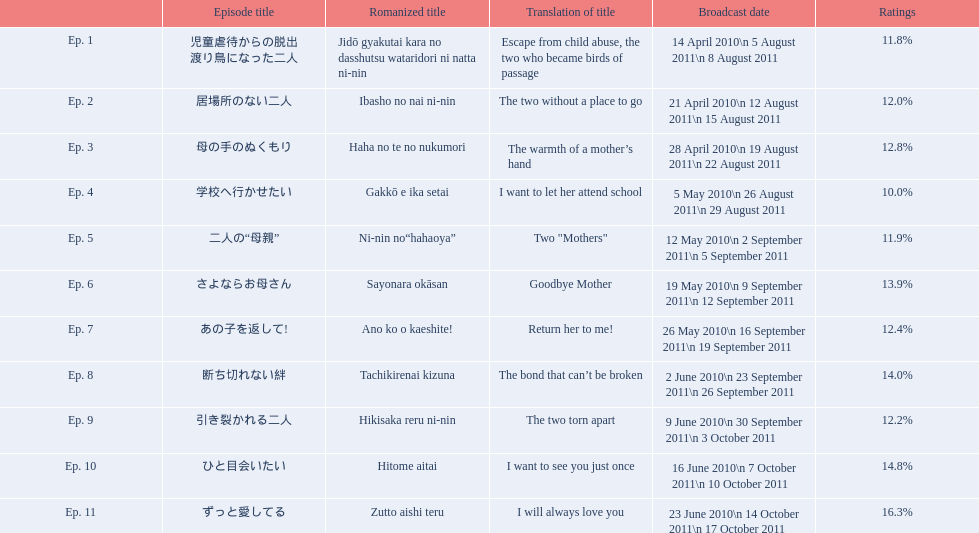What is the number of episodes with a continuous rating of over 11%? 7. 